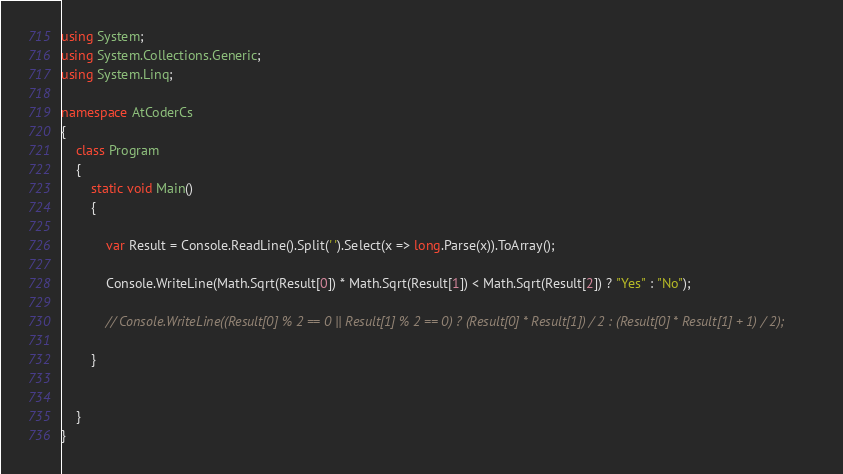Convert code to text. <code><loc_0><loc_0><loc_500><loc_500><_C#_>using System;
using System.Collections.Generic;
using System.Linq;

namespace AtCoderCs
{
    class Program
    {
        static void Main()
        {

            var Result = Console.ReadLine().Split(' ').Select(x => long.Parse(x)).ToArray();

            Console.WriteLine(Math.Sqrt(Result[0]) * Math.Sqrt(Result[1]) < Math.Sqrt(Result[2]) ? "Yes" : "No");

            // Console.WriteLine((Result[0] % 2 == 0 || Result[1] % 2 == 0) ? (Result[0] * Result[1]) / 2 : (Result[0] * Result[1] + 1) / 2);

        }


    }
}
</code> 